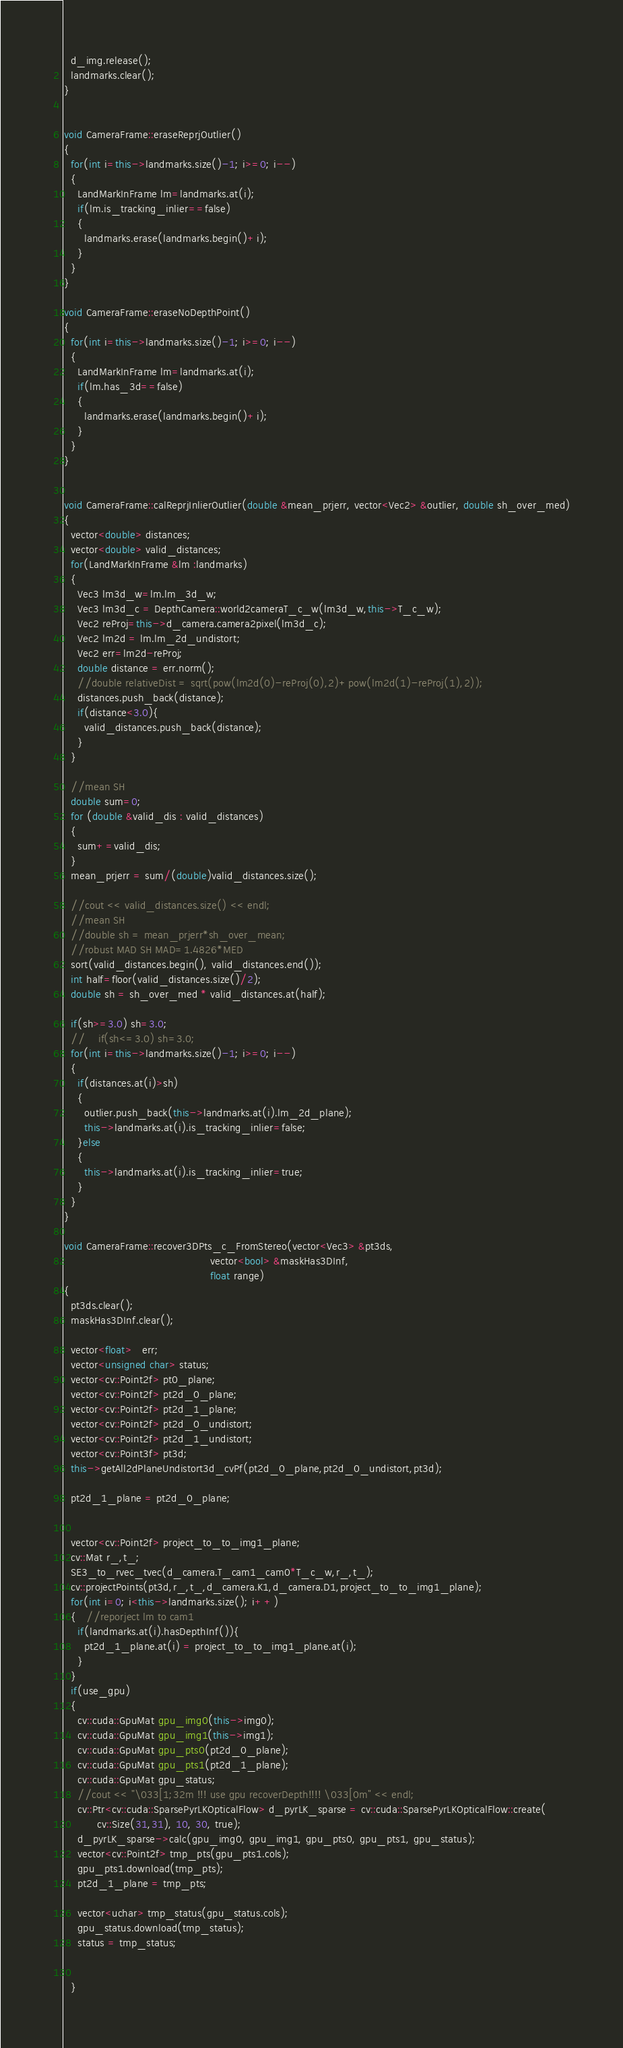<code> <loc_0><loc_0><loc_500><loc_500><_C++_>  d_img.release();
  landmarks.clear();
}


void CameraFrame::eraseReprjOutlier()
{
  for(int i=this->landmarks.size()-1; i>=0; i--)
  {
    LandMarkInFrame lm=landmarks.at(i);
    if(lm.is_tracking_inlier==false)
    {
      landmarks.erase(landmarks.begin()+i);
    }
  }
}

void CameraFrame::eraseNoDepthPoint()
{
  for(int i=this->landmarks.size()-1; i>=0; i--)
  {
    LandMarkInFrame lm=landmarks.at(i);
    if(lm.has_3d==false)
    {
      landmarks.erase(landmarks.begin()+i);
    }
  }
}


void CameraFrame::calReprjInlierOutlier(double &mean_prjerr, vector<Vec2> &outlier, double sh_over_med)
{
  vector<double> distances;
  vector<double> valid_distances;
  for(LandMarkInFrame &lm :landmarks)
  {
    Vec3 lm3d_w=lm.lm_3d_w;
    Vec3 lm3d_c = DepthCamera::world2cameraT_c_w(lm3d_w,this->T_c_w);
    Vec2 reProj=this->d_camera.camera2pixel(lm3d_c);
    Vec2 lm2d = lm.lm_2d_undistort;
    Vec2 err=lm2d-reProj;
    double distance = err.norm();
    //double relativeDist = sqrt(pow(lm2d(0)-reProj(0),2)+pow(lm2d(1)-reProj(1),2));
    distances.push_back(distance);
    if(distance<3.0){
      valid_distances.push_back(distance);
    }
  }

  //mean SH
  double sum=0;
  for (double &valid_dis : valid_distances)
  {
    sum+=valid_dis;
  }
  mean_prjerr = sum/(double)valid_distances.size();

  //cout << valid_distances.size() << endl;
  //mean SH
  //double sh = mean_prjerr*sh_over_mean;
  //robust MAD SH MAD=1.4826*MED
  sort(valid_distances.begin(), valid_distances.end());
  int half=floor(valid_distances.size()/2);
  double sh = sh_over_med * valid_distances.at(half);

  if(sh>=3.0) sh=3.0;
  //    if(sh<=3.0) sh=3.0;
  for(int i=this->landmarks.size()-1; i>=0; i--)
  {
    if(distances.at(i)>sh)
    {
      outlier.push_back(this->landmarks.at(i).lm_2d_plane);
      this->landmarks.at(i).is_tracking_inlier=false;
    }else
    {
      this->landmarks.at(i).is_tracking_inlier=true;
    }
  }
}

void CameraFrame::recover3DPts_c_FromStereo(vector<Vec3> &pt3ds,
                                            vector<bool> &maskHas3DInf,
                                            float range)
{
  pt3ds.clear();
  maskHas3DInf.clear();

  vector<float>   err;
  vector<unsigned char> status;
  vector<cv::Point2f> pt0_plane;
  vector<cv::Point2f> pt2d_0_plane;
  vector<cv::Point2f> pt2d_1_plane;
  vector<cv::Point2f> pt2d_0_undistort;
  vector<cv::Point2f> pt2d_1_undistort;
  vector<cv::Point3f> pt3d;
  this->getAll2dPlaneUndistort3d_cvPf(pt2d_0_plane,pt2d_0_undistort,pt3d);

  pt2d_1_plane = pt2d_0_plane;


  vector<cv::Point2f> project_to_to_img1_plane;
  cv::Mat r_,t_;
  SE3_to_rvec_tvec(d_camera.T_cam1_cam0*T_c_w,r_,t_);
  cv::projectPoints(pt3d,r_,t_,d_camera.K1,d_camera.D1,project_to_to_img1_plane);
  for(int i=0; i<this->landmarks.size(); i++)
  {   //reporject lm to cam1
    if(landmarks.at(i).hasDepthInf()){
      pt2d_1_plane.at(i) = project_to_to_img1_plane.at(i);
    }
  }
  if(use_gpu)
  {
    cv::cuda::GpuMat gpu_img0(this->img0);
    cv::cuda::GpuMat gpu_img1(this->img1);
    cv::cuda::GpuMat gpu_pts0(pt2d_0_plane);
    cv::cuda::GpuMat gpu_pts1(pt2d_1_plane);
    cv::cuda::GpuMat gpu_status;
    //cout << "\033[1;32m !!! use gpu recoverDepth!!!! \033[0m" << endl;
    cv::Ptr<cv::cuda::SparsePyrLKOpticalFlow> d_pyrLK_sparse = cv::cuda::SparsePyrLKOpticalFlow::create(
          cv::Size(31,31), 10, 30, true);
    d_pyrLK_sparse->calc(gpu_img0, gpu_img1, gpu_pts0, gpu_pts1, gpu_status);
    vector<cv::Point2f> tmp_pts(gpu_pts1.cols);
    gpu_pts1.download(tmp_pts);
    pt2d_1_plane = tmp_pts;

    vector<uchar> tmp_status(gpu_status.cols);
    gpu_status.download(tmp_status);
    status = tmp_status;


  }</code> 